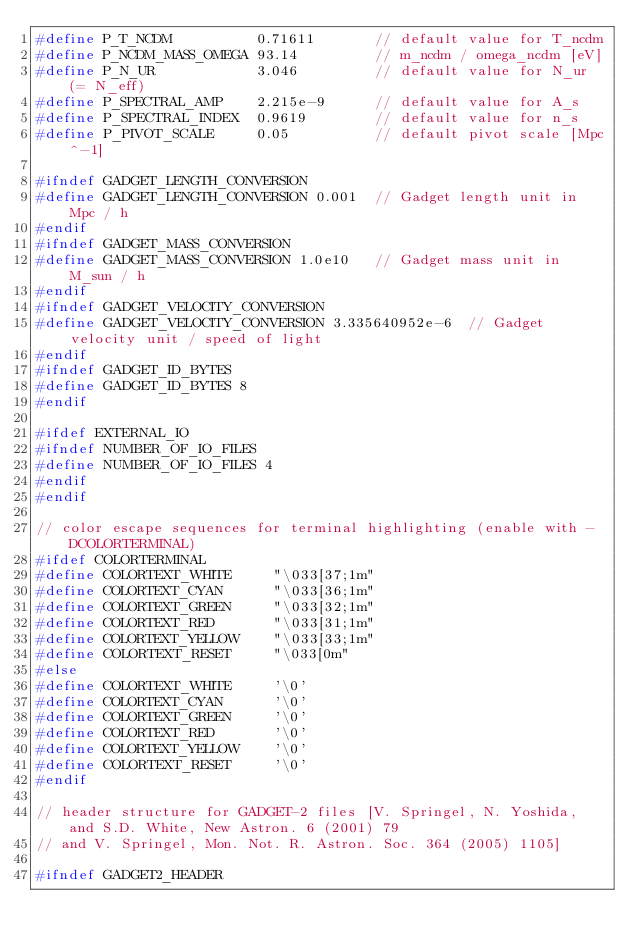<code> <loc_0><loc_0><loc_500><loc_500><_C++_>#define P_T_NCDM          0.71611       // default value for T_ncdm
#define P_NCDM_MASS_OMEGA 93.14         // m_ncdm / omega_ncdm [eV]
#define P_N_UR            3.046         // default value for N_ur (= N_eff)
#define P_SPECTRAL_AMP    2.215e-9      // default value for A_s
#define P_SPECTRAL_INDEX  0.9619        // default value for n_s
#define P_PIVOT_SCALE     0.05          // default pivot scale [Mpc^-1]

#ifndef GADGET_LENGTH_CONVERSION
#define GADGET_LENGTH_CONVERSION 0.001  // Gadget length unit in Mpc / h
#endif
#ifndef GADGET_MASS_CONVERSION
#define GADGET_MASS_CONVERSION 1.0e10   // Gadget mass unit in M_sun / h
#endif
#ifndef GADGET_VELOCITY_CONVERSION
#define GADGET_VELOCITY_CONVERSION 3.335640952e-6  // Gadget velocity unit / speed of light
#endif
#ifndef GADGET_ID_BYTES
#define GADGET_ID_BYTES 8
#endif

#ifdef EXTERNAL_IO
#ifndef NUMBER_OF_IO_FILES
#define NUMBER_OF_IO_FILES 4
#endif
#endif

// color escape sequences for terminal highlighting (enable with -DCOLORTERMINAL)
#ifdef COLORTERMINAL
#define COLORTEXT_WHITE     "\033[37;1m"
#define COLORTEXT_CYAN      "\033[36;1m"
#define COLORTEXT_GREEN     "\033[32;1m"
#define COLORTEXT_RED       "\033[31;1m"
#define COLORTEXT_YELLOW    "\033[33;1m"
#define COLORTEXT_RESET     "\033[0m"
#else
#define COLORTEXT_WHITE     '\0'
#define COLORTEXT_CYAN      '\0'
#define COLORTEXT_GREEN     '\0'
#define COLORTEXT_RED       '\0'
#define COLORTEXT_YELLOW    '\0'
#define COLORTEXT_RESET     '\0'
#endif

// header structure for GADGET-2 files [V. Springel, N. Yoshida, and S.D. White, New Astron. 6 (2001) 79
// and V. Springel, Mon. Not. R. Astron. Soc. 364 (2005) 1105]

#ifndef GADGET2_HEADER</code> 